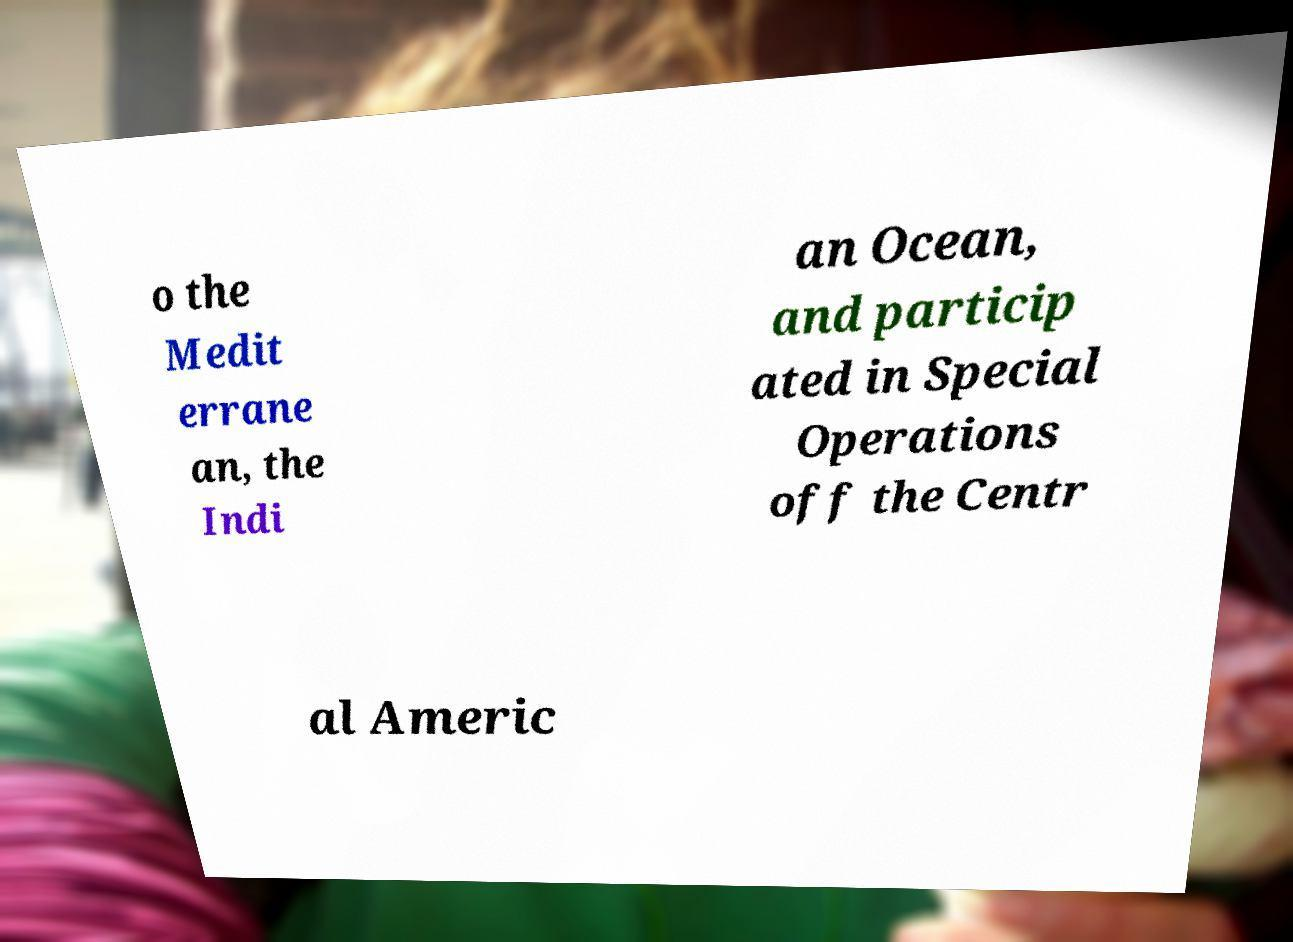Please identify and transcribe the text found in this image. o the Medit errane an, the Indi an Ocean, and particip ated in Special Operations off the Centr al Americ 